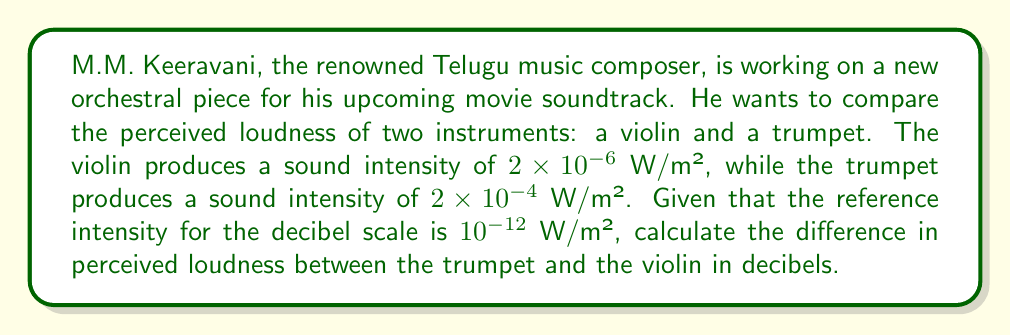Can you answer this question? To solve this problem, we need to use the formula for sound intensity level in decibels:

$$ \text{SIL} = 10 \log_{10}\left(\frac{I}{I_0}\right) \text{ dB} $$

Where:
$\text{SIL}$ is the Sound Intensity Level in decibels
$I$ is the intensity of the sound in W/m²
$I_0$ is the reference intensity ($10^{-12}$ W/m²)

Let's calculate the SIL for each instrument:

1. For the violin:
$$ \text{SIL}_{\text{violin}} = 10 \log_{10}\left(\frac{2 \times 10^{-6}}{10^{-12}}\right) = 10 \log_{10}(2 \times 10^6) = 10 \times 6.30 = 63.0 \text{ dB} $$

2. For the trumpet:
$$ \text{SIL}_{\text{trumpet}} = 10 \log_{10}\left(\frac{2 \times 10^{-4}}{10^{-12}}\right) = 10 \log_{10}(2 \times 10^8) = 10 \times 8.30 = 83.0 \text{ dB} $$

To find the difference in perceived loudness, we subtract the violin's SIL from the trumpet's SIL:

$$ \text{Difference} = \text{SIL}_{\text{trumpet}} - \text{SIL}_{\text{violin}} = 83.0 - 63.0 = 20.0 \text{ dB} $$
Answer: The difference in perceived loudness between the trumpet and the violin is 20.0 dB. 